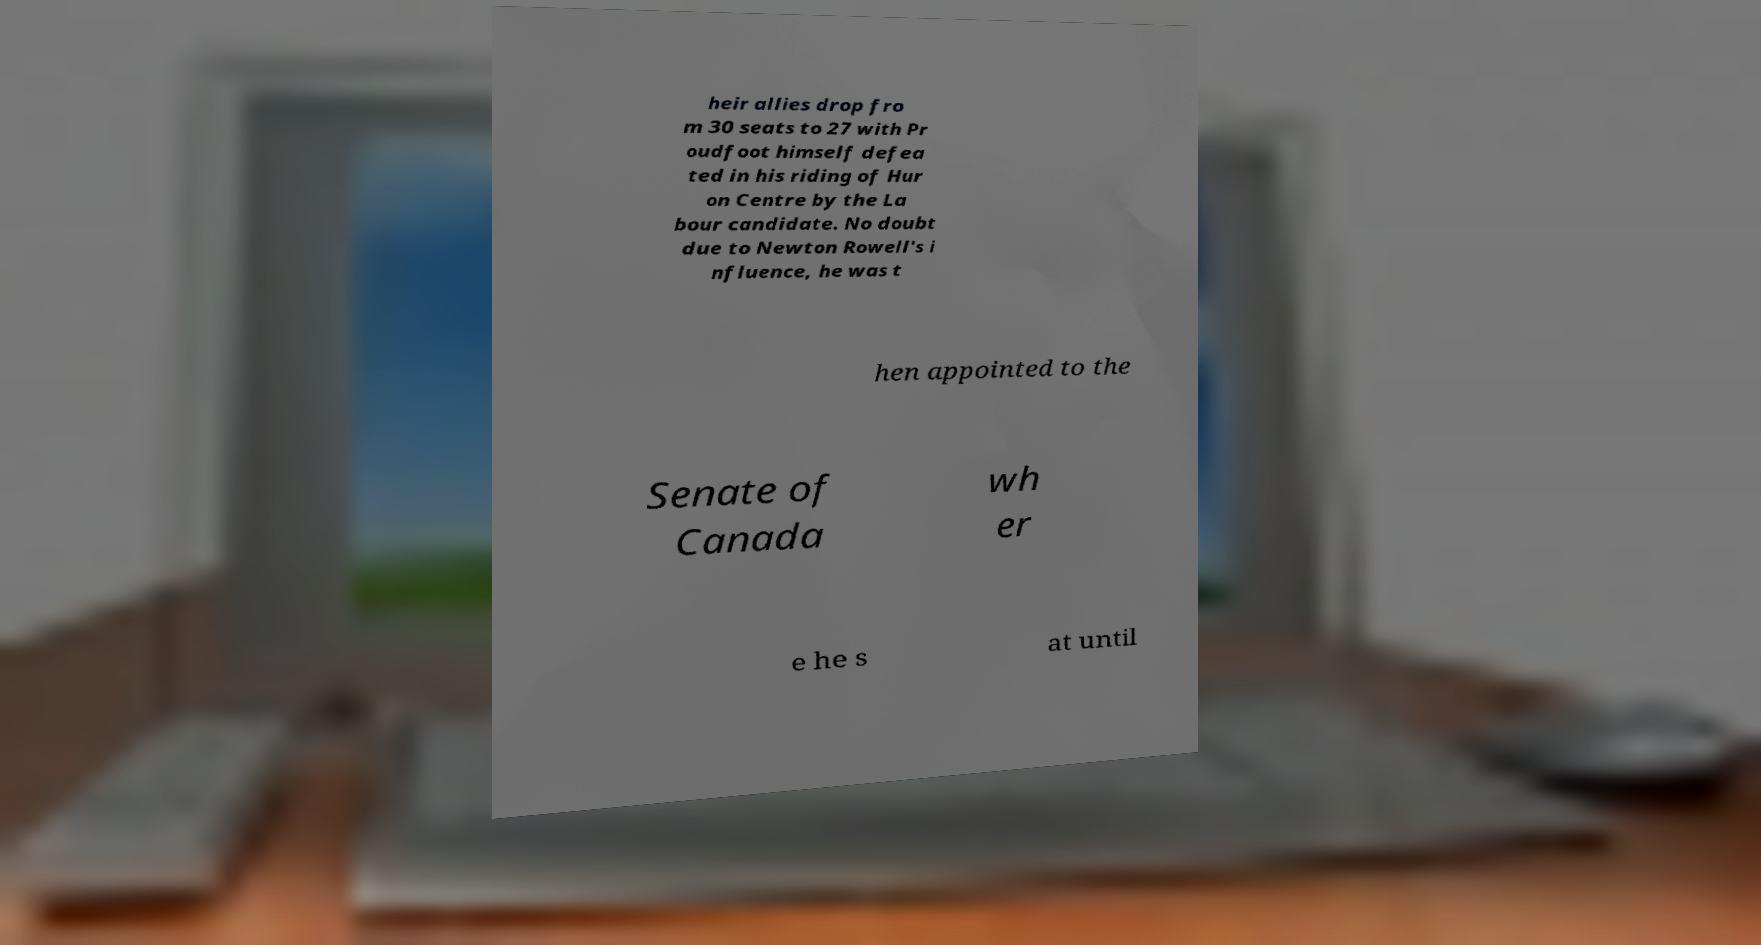What messages or text are displayed in this image? I need them in a readable, typed format. heir allies drop fro m 30 seats to 27 with Pr oudfoot himself defea ted in his riding of Hur on Centre by the La bour candidate. No doubt due to Newton Rowell's i nfluence, he was t hen appointed to the Senate of Canada wh er e he s at until 